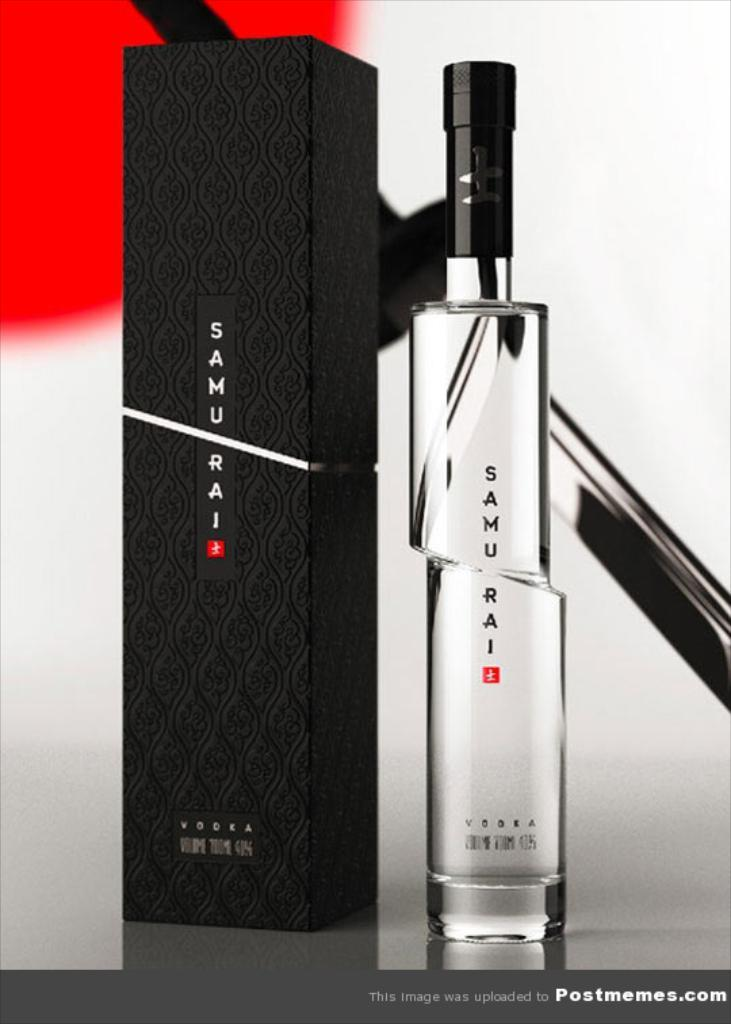<image>
Share a concise interpretation of the image provided. A bottle of Samurai Vodka next to the bottle it came in. 